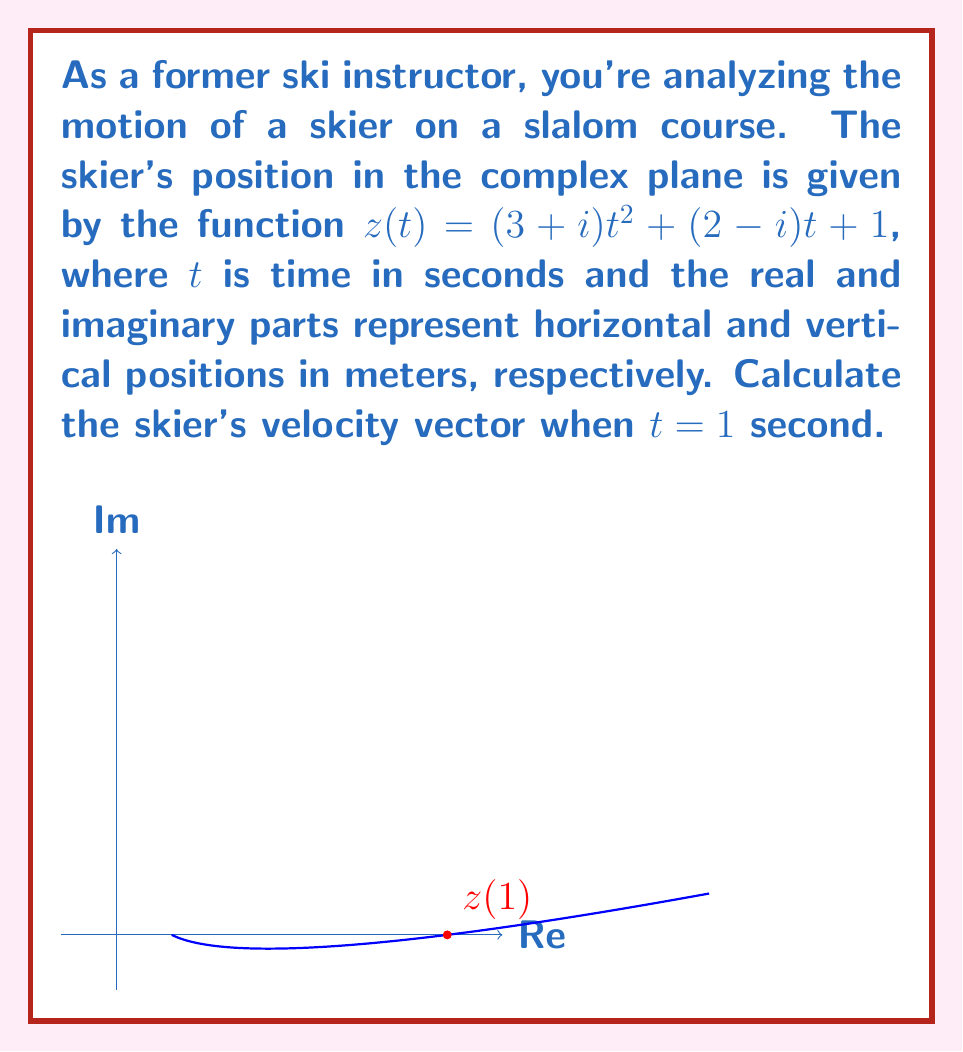What is the answer to this math problem? Let's approach this step-by-step:

1) The position function is given as $z(t) = (3+i)t^2 + (2-i)t + 1$

2) To find the velocity, we need to differentiate $z(t)$ with respect to $t$:

   $$\frac{dz}{dt} = 2(3+i)t + (2-i)$$

3) This gives us the velocity function. To find the velocity at $t=1$, we substitute $t=1$:

   $$v(1) = 2(3+i)(1) + (2-i)$$

4) Simplify:
   $$v(1) = (6+2i) + (2-i)$$
   $$v(1) = 8+i$$

5) This complex number represents the velocity vector. The real part (8) is the horizontal component, and the imaginary part (1) is the vertical component of the velocity.

6) To interpret this physically:
   - The skier is moving 8 meters per second horizontally
   - The skier is moving 1 meter per second vertically

7) The magnitude of the velocity (speed) can be calculated as:

   $$|v(1)| = \sqrt{8^2 + 1^2} = \sqrt{65} \approx 8.06 \text{ m/s}$$

8) The direction of the velocity vector is:

   $$\theta = \tan^{-1}\left(\frac{1}{8}\right) \approx 7.13°$$

   This angle is measured from the positive real axis (horizontal).
Answer: $v(1) = 8+i$ m/s 